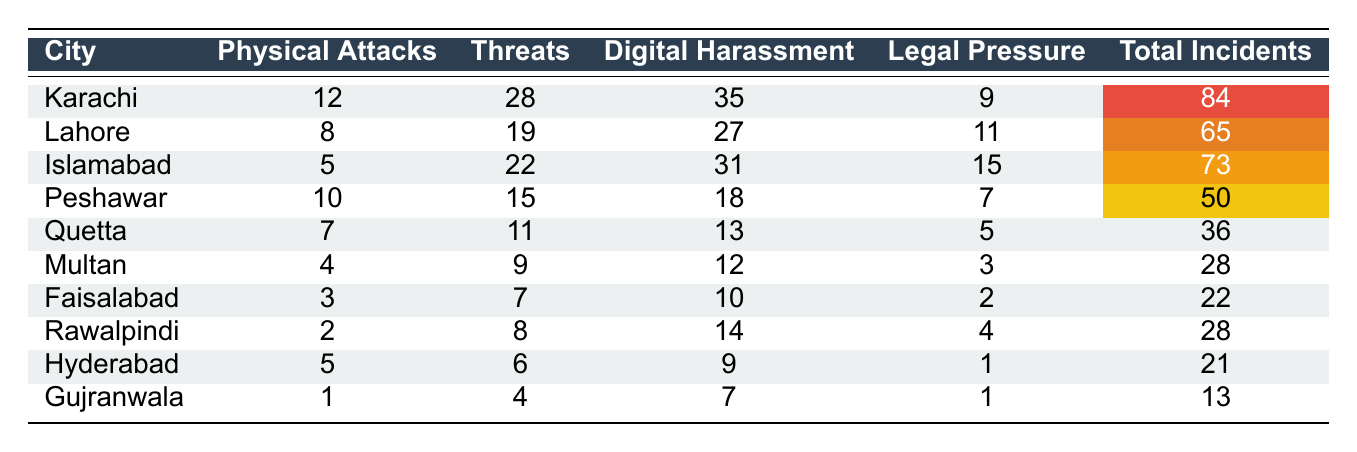What city reported the highest number of total incidents? By examining the 'Total Incidents' column, Karachi has the highest total with 84 incidents compared to other cities.
Answer: Karachi How many physical attacks were reported in Lahore? The 'Physical Attacks' column indicates that Lahore had 8 reported attacks.
Answer: 8 What is the total number of incidents in Quetta? The table shows that Quetta had a total of 36 incidents listed in the 'Total Incidents' column.
Answer: 36 Did Peshawar report more threats or physical attacks? Peshawar had 10 physical attacks and 15 threats. Since 15 is greater than 10, threats were higher.
Answer: Yes, threats were higher What is the average number of digital harassment incidents across all cities? Adding the digital harassment incidents (35 + 27 + 31 + 18 + 13 + 12 + 10 + 14 + 9 + 7 =  272) and dividing by the number of cities (10) gives an average of 27.2 incidents.
Answer: 27.2 Which city had the least incidents of legal pressure? In the 'Legal Pressure' column, Faisalabad had the least with 2 incidents.
Answer: Faisalabad How do the total incidents in Islamabad compare to those in Multan? Islamabad has 73 total incidents, while Multan has 28. This shows that Islamabad has more incidents than Multan by 45.
Answer: Islamabad has 45 more incidents Is it true that every city reported more threats than physical attacks? By checking each city's data, only Faisalabad (3 physical attacks) and Gujranwala (1 physical attack) did not report more threats than attacks. Therefore, the statement is false.
Answer: No Which city experienced digital harassment incidents that were higher than the average number of physical attacks across all cities? The average number of physical attacks is 6.5 (totaling 65 attacks across 10 cities), and Karachi (35) and Islamabad (31) both reported higher digital harassment incidents.
Answer: Karachi and Islamabad What is the total difference between physical attacks in Karachi and Gujranwala? Karachi reported 12 physical attacks, while Gujranwala reported 1, resulting in a difference of 11 attacks (12 - 1 = 11).
Answer: 11 